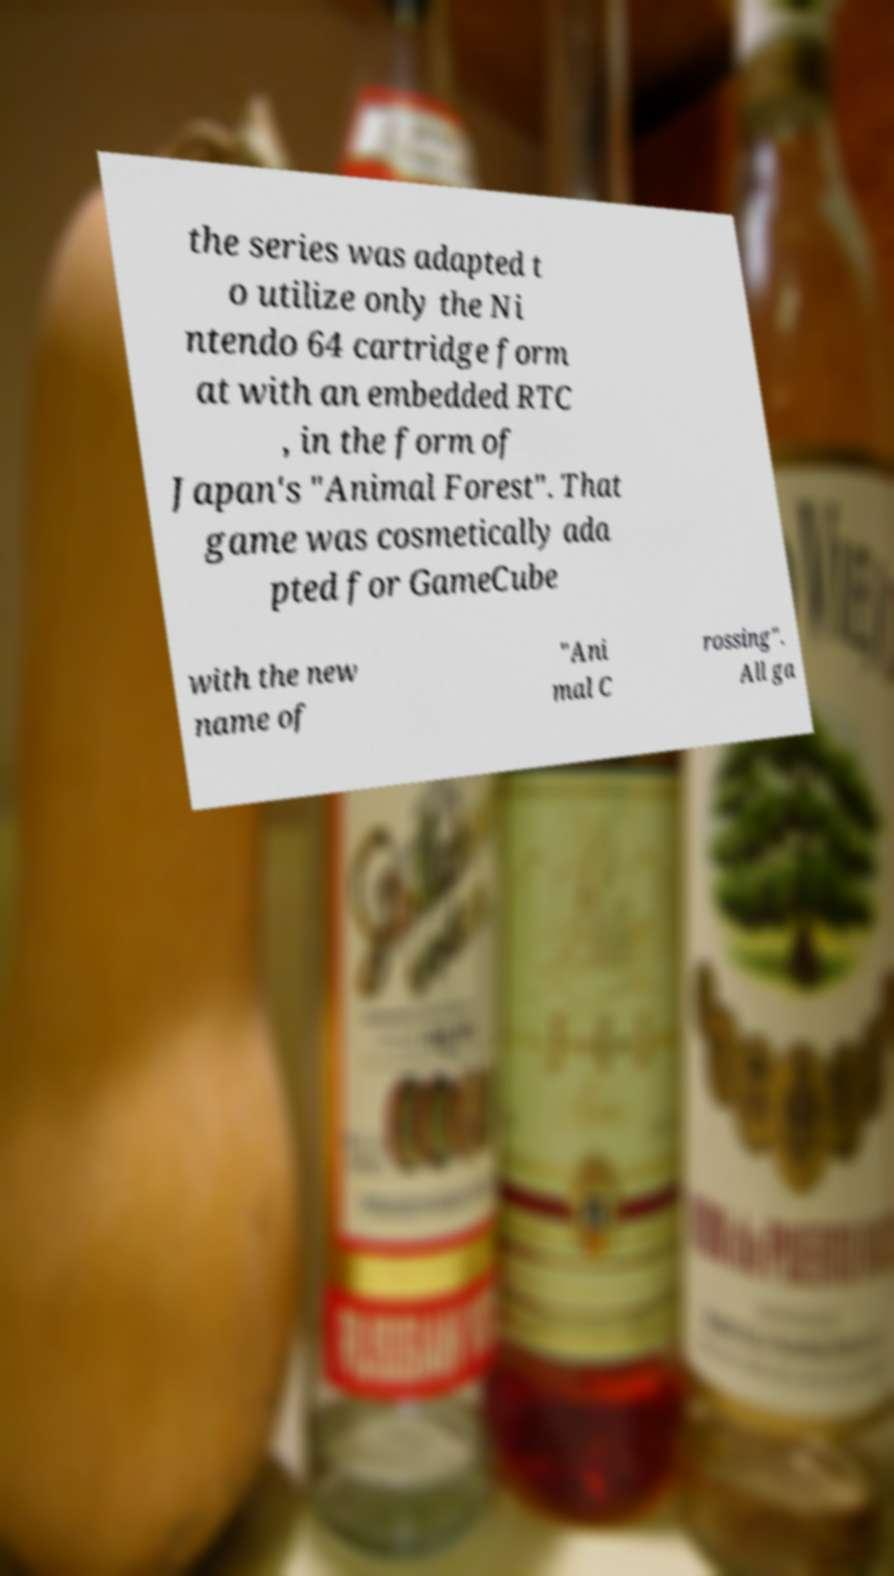Please read and relay the text visible in this image. What does it say? the series was adapted t o utilize only the Ni ntendo 64 cartridge form at with an embedded RTC , in the form of Japan's "Animal Forest". That game was cosmetically ada pted for GameCube with the new name of "Ani mal C rossing". All ga 